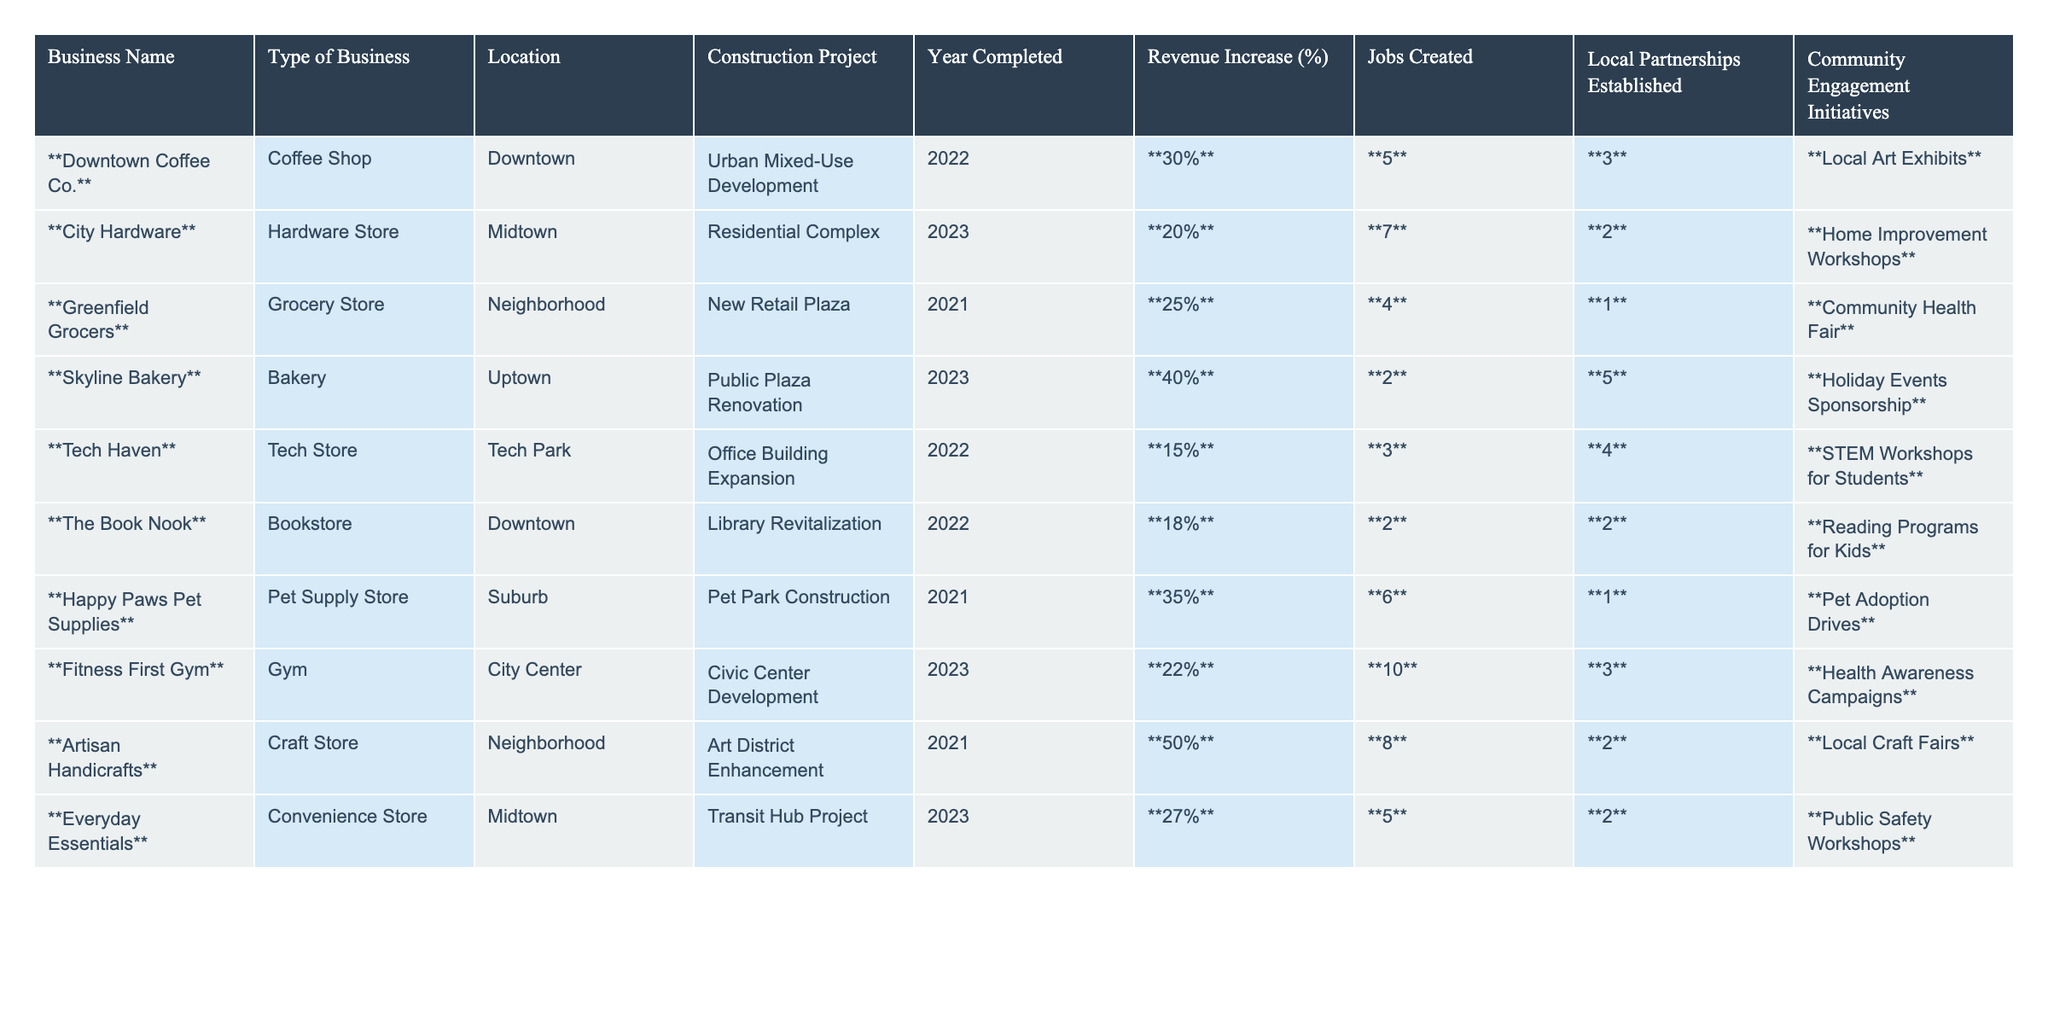What is the revenue increase percentage for Downtown Coffee Co.? The table indicates the revenue increase percentage for Downtown Coffee Co. as shown in the respective column, which is bolded: **30%**.
Answer: 30% How many jobs were created by the Skyline Bakery? Looking at the table, the number of jobs created by Skyline Bakery is listed in the corresponding column, which is **2**.
Answer: 2 Which business established the highest number of local partnerships? By reviewing the local partnerships established, Artisan Handicrafts has the highest value, **2**, as it appears in the table.
Answer: 2 What is the average revenue increase percentage for all businesses listed? To find the average, first sum the revenue increase percentages: 30 + 20 + 25 + 40 + 15 + 18 + 35 + 22 + 50 + 27 =  292. Then divide by the total number of businesses (10): 292/10 = 29.2%.
Answer: 29.2% Which business had a revenue increase of over 35%? By scanning through the revenue increase percentages, both Skyline Bakery (40%) and Happy Paws Pet Supplies (35%) have over 35%.
Answer: Yes How many total jobs were created across all businesses? To get the total number of jobs created, sum the individual job counts: 5 + 7 + 4 + 2 + 3 + 2 + 6 + 10 + 8 + 5 = 52 jobs in total.
Answer: 52 Is there a business that established 5 local partnerships? Observing the table, only Skyline Bakery has established 5 local partnerships, as indicated in its row.
Answer: Yes Which business had the highest revenue increase percentage, and what was that percentage? By comparing the revenue increase percentages, Artisan Handicrafts has the highest at **50%**.
Answer: Artisan Handicrafts, 50% How many businesses are located in the Downtown area? The table shows Downtown Coffee Co. and The Book Nook listed under the location "Downtown," which totals 2 businesses.
Answer: 2 Which construction project resulted in the least revenue increase? By reviewing the revenue increase percentages, Tech Haven shows the least increase, which is **15%**.
Answer: 15% 